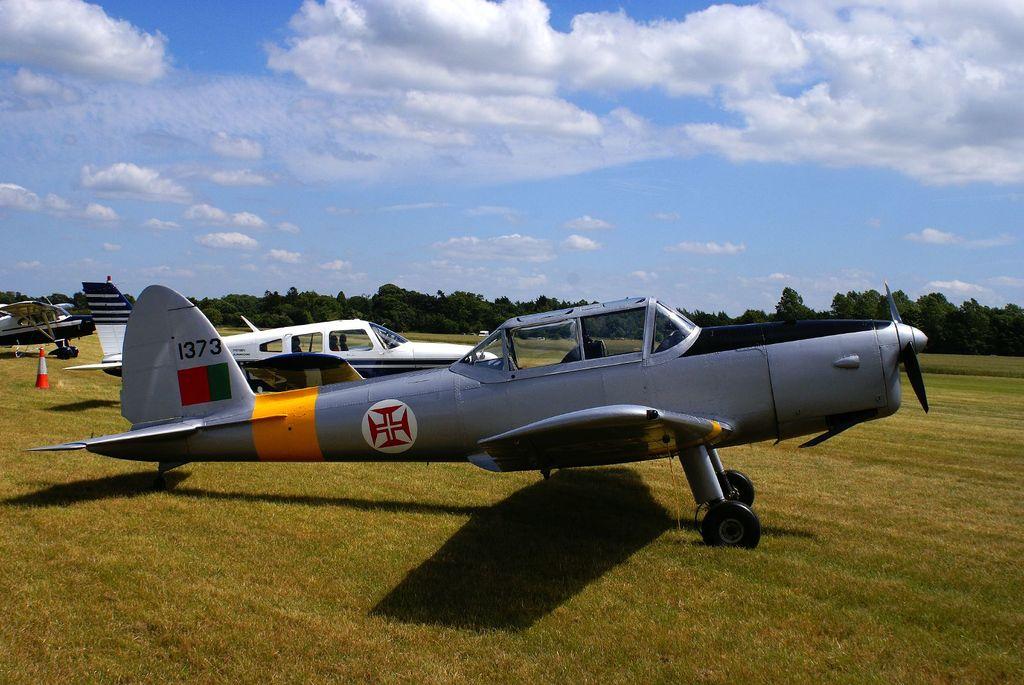What 4 digit number is written on the rear of the grey plane?
Keep it short and to the point. 1373. 